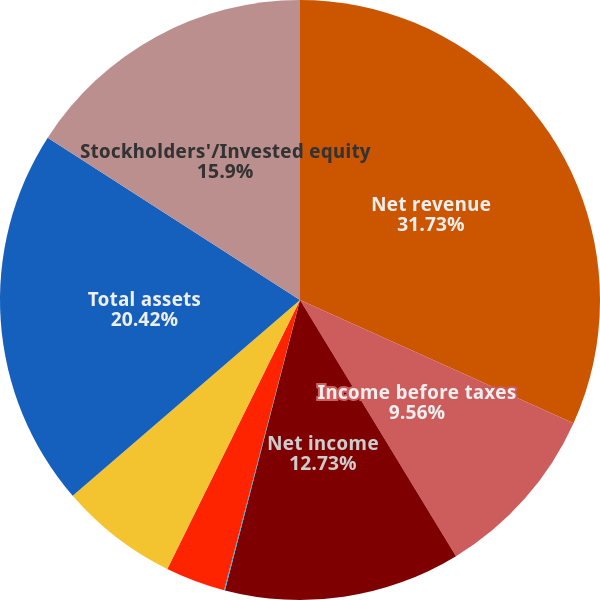Convert chart. <chart><loc_0><loc_0><loc_500><loc_500><pie_chart><fcel>Net revenue<fcel>Income before taxes<fcel>Net income<fcel>Basic and diluted net income<fcel>Basic and diluted average<fcel>Working capital<fcel>Total assets<fcel>Stockholders'/Invested equity<nl><fcel>31.74%<fcel>9.56%<fcel>12.73%<fcel>0.05%<fcel>3.22%<fcel>6.39%<fcel>20.42%<fcel>15.9%<nl></chart> 